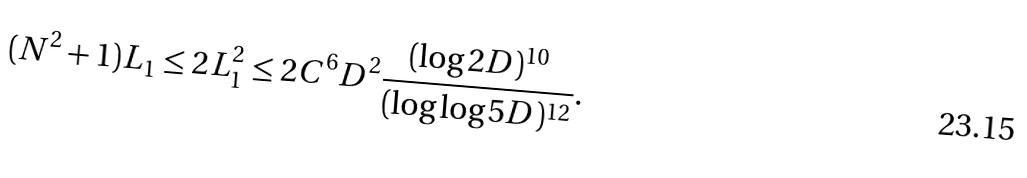<formula> <loc_0><loc_0><loc_500><loc_500>( N ^ { 2 } + 1 ) L _ { 1 } \leq 2 L _ { 1 } ^ { 2 } \leq 2 C ^ { 6 } D ^ { 2 } \frac { ( \log 2 D ) ^ { 1 0 } } { ( \log \log 5 D ) ^ { 1 2 } } .</formula> 